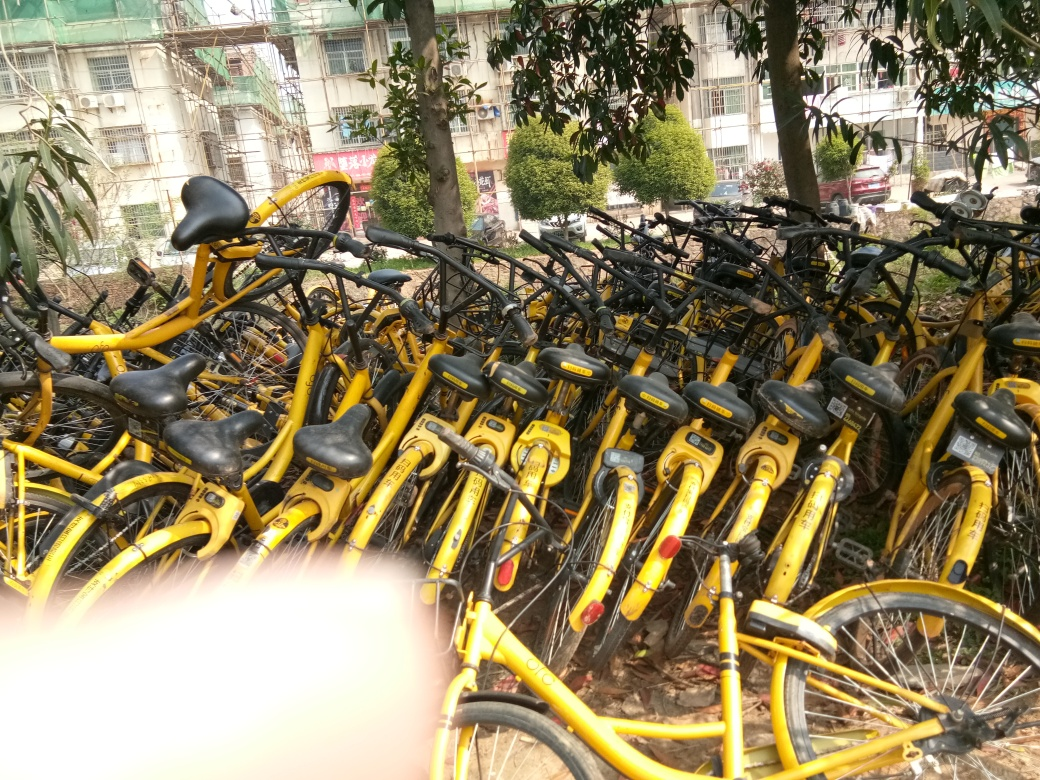Describe the setting where these bicycles are stored. The bicycles are stored outdoors, in an unsheltered area that appears to be a parking space or storage area specifically designated for them. There’s a building in the background and some greenery, suggesting this could be near a park, campus, or similar public space. 